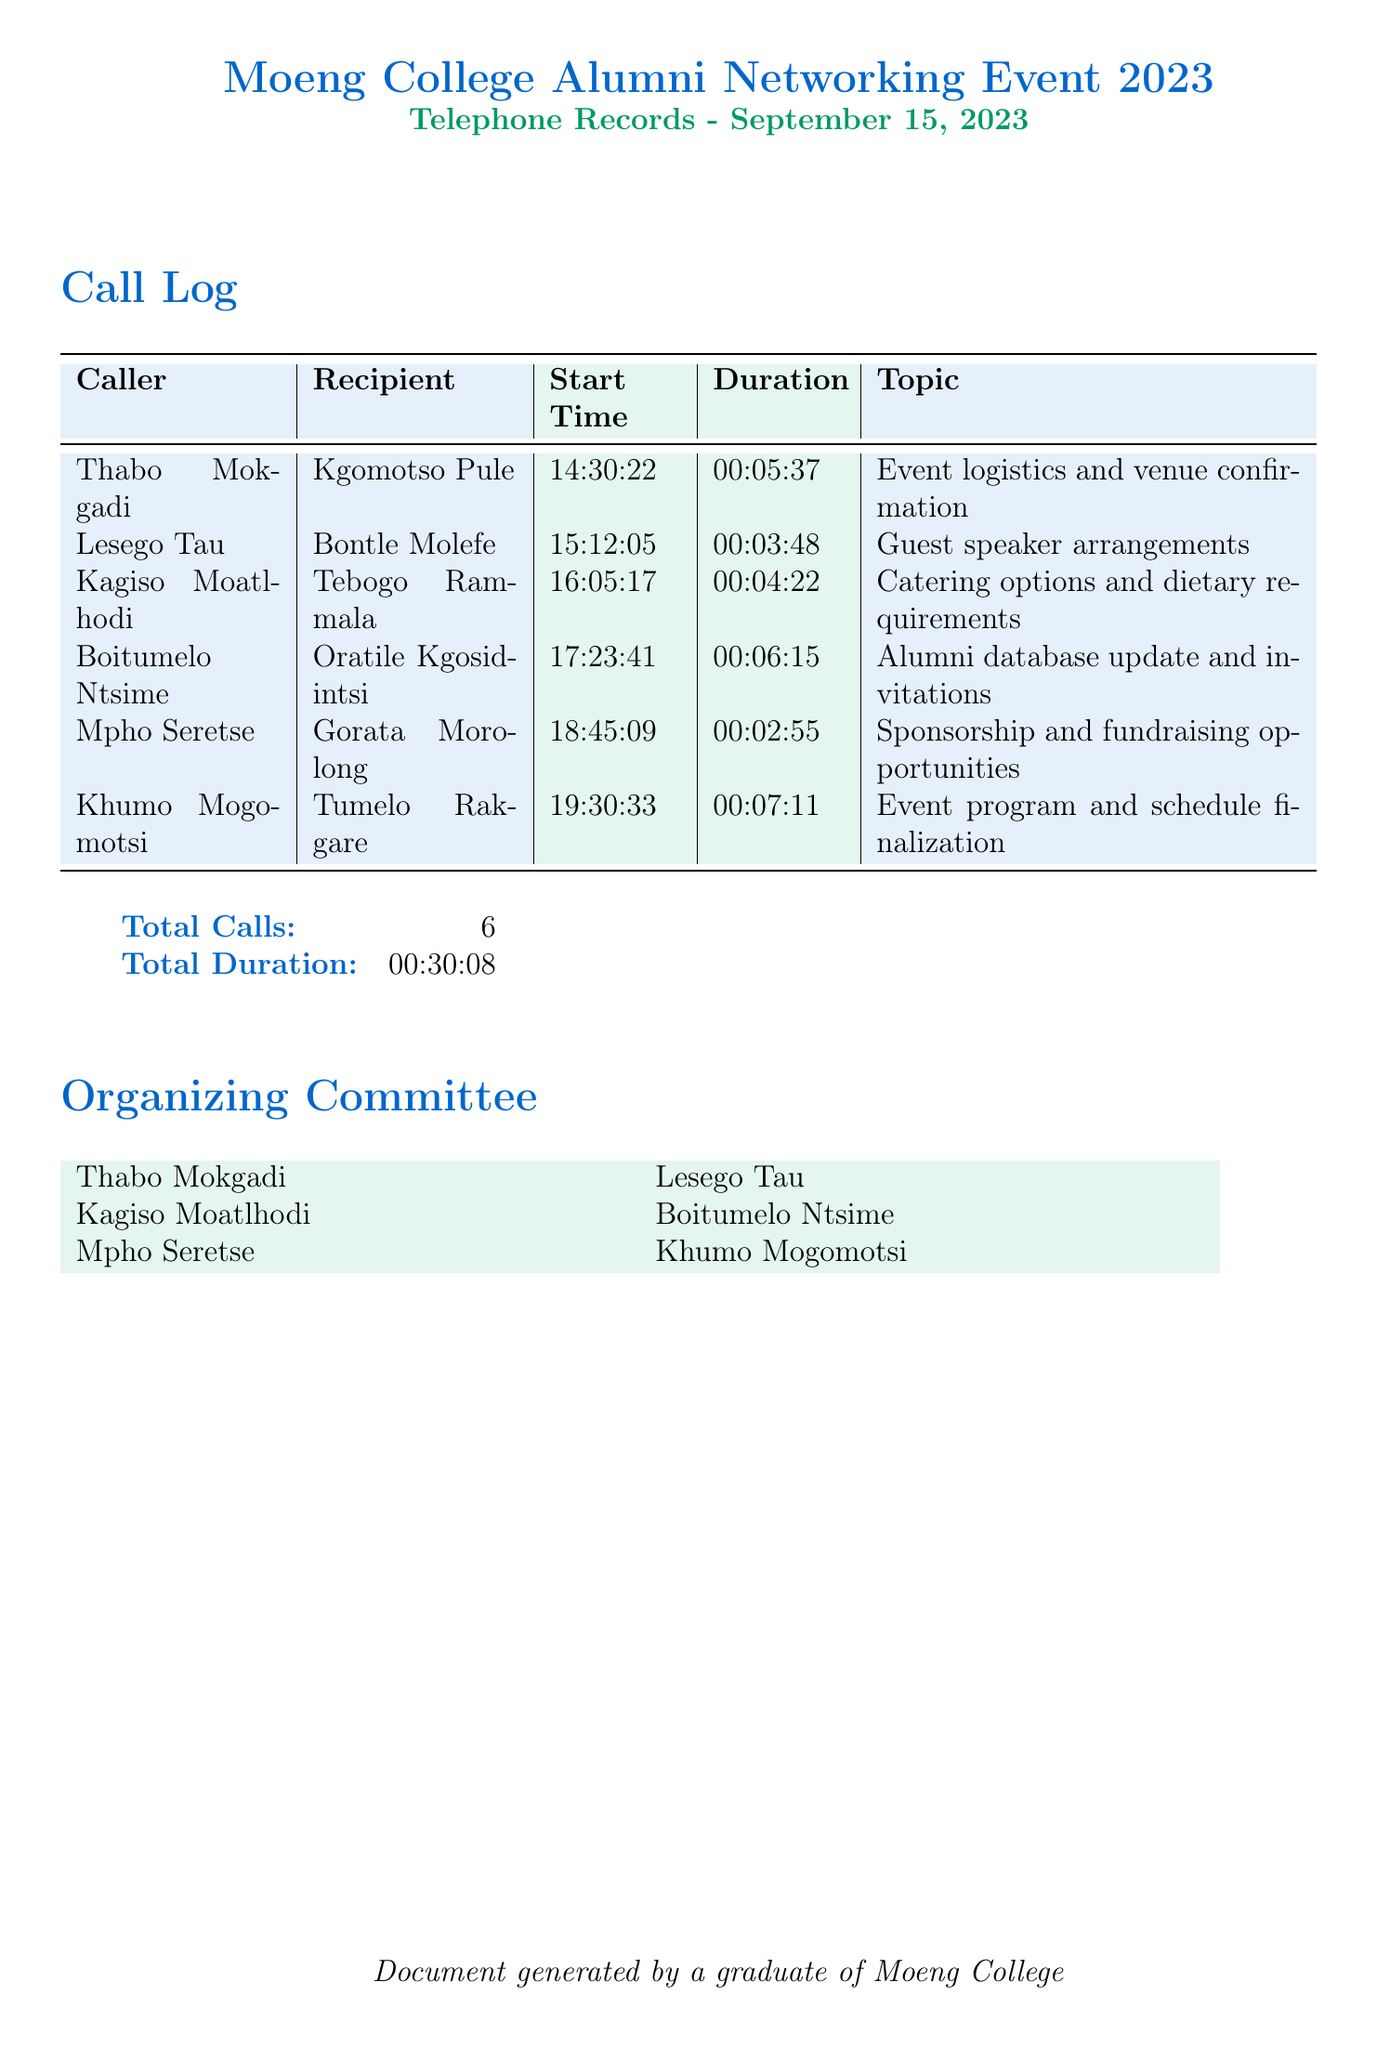What is the date of the telephone records? The date of the telephone records is specified at the top of the document as September 15, 2023.
Answer: September 15, 2023 Who called Kgomotso Pule? The caller information is listed in the call log, and Thabo Mokgadi is shown to have called Kgomotso Pule.
Answer: Thabo Mokgadi What was the duration of the call between Khumo Mogomotsi and Tumelo Rakgare? The duration is recorded next to the call in the document, and it is 00:07:11.
Answer: 00:07:11 How many total calls were made? The summary at the bottom of the document states the total number of calls made, which is 6.
Answer: 6 What was the topic of the call between Kagiso Moatlhodi and Tebogo Rammala? The topic is noted alongside the call details, which indicates that it was catering options and dietary requirements.
Answer: Catering options and dietary requirements Who organized the event? The organizing committee is listed at the end of the document, comprising Thabo Mokgadi, Lesego Tau, Kagiso Moatlhodi, Boitumelo Ntsime, Mpho Seretse, and Khumo Mogomotsi.
Answer: Thabo Mokgadi, Lesego Tau, Kagiso Moatlhodi, Boitumelo Ntsime, Mpho Seretse, Khumo Mogomotsi What was the total duration of all calls? The total duration is provided in the summary section of the document, amounting to 00:30:08.
Answer: 00:30:08 Which topic was discussed in the last call recorded? The last call in the log addressed event program and schedule finalization, as noted in the topic column.
Answer: Event program and schedule finalization 